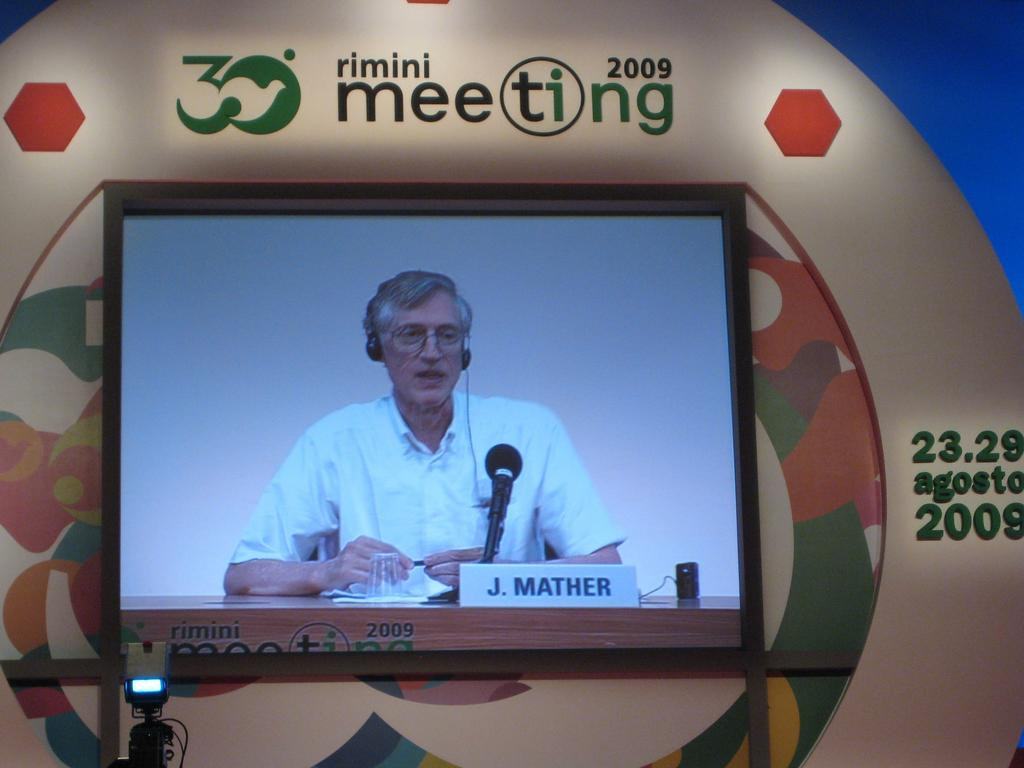<image>
Render a clear and concise summary of the photo. J. Mather taking to people at the rimini meeting in 2009. 